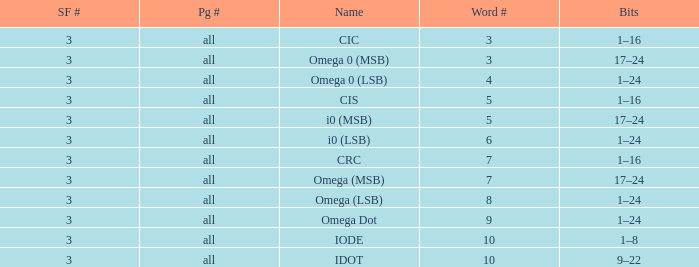What is the word count that is named omega dot? 9.0. 